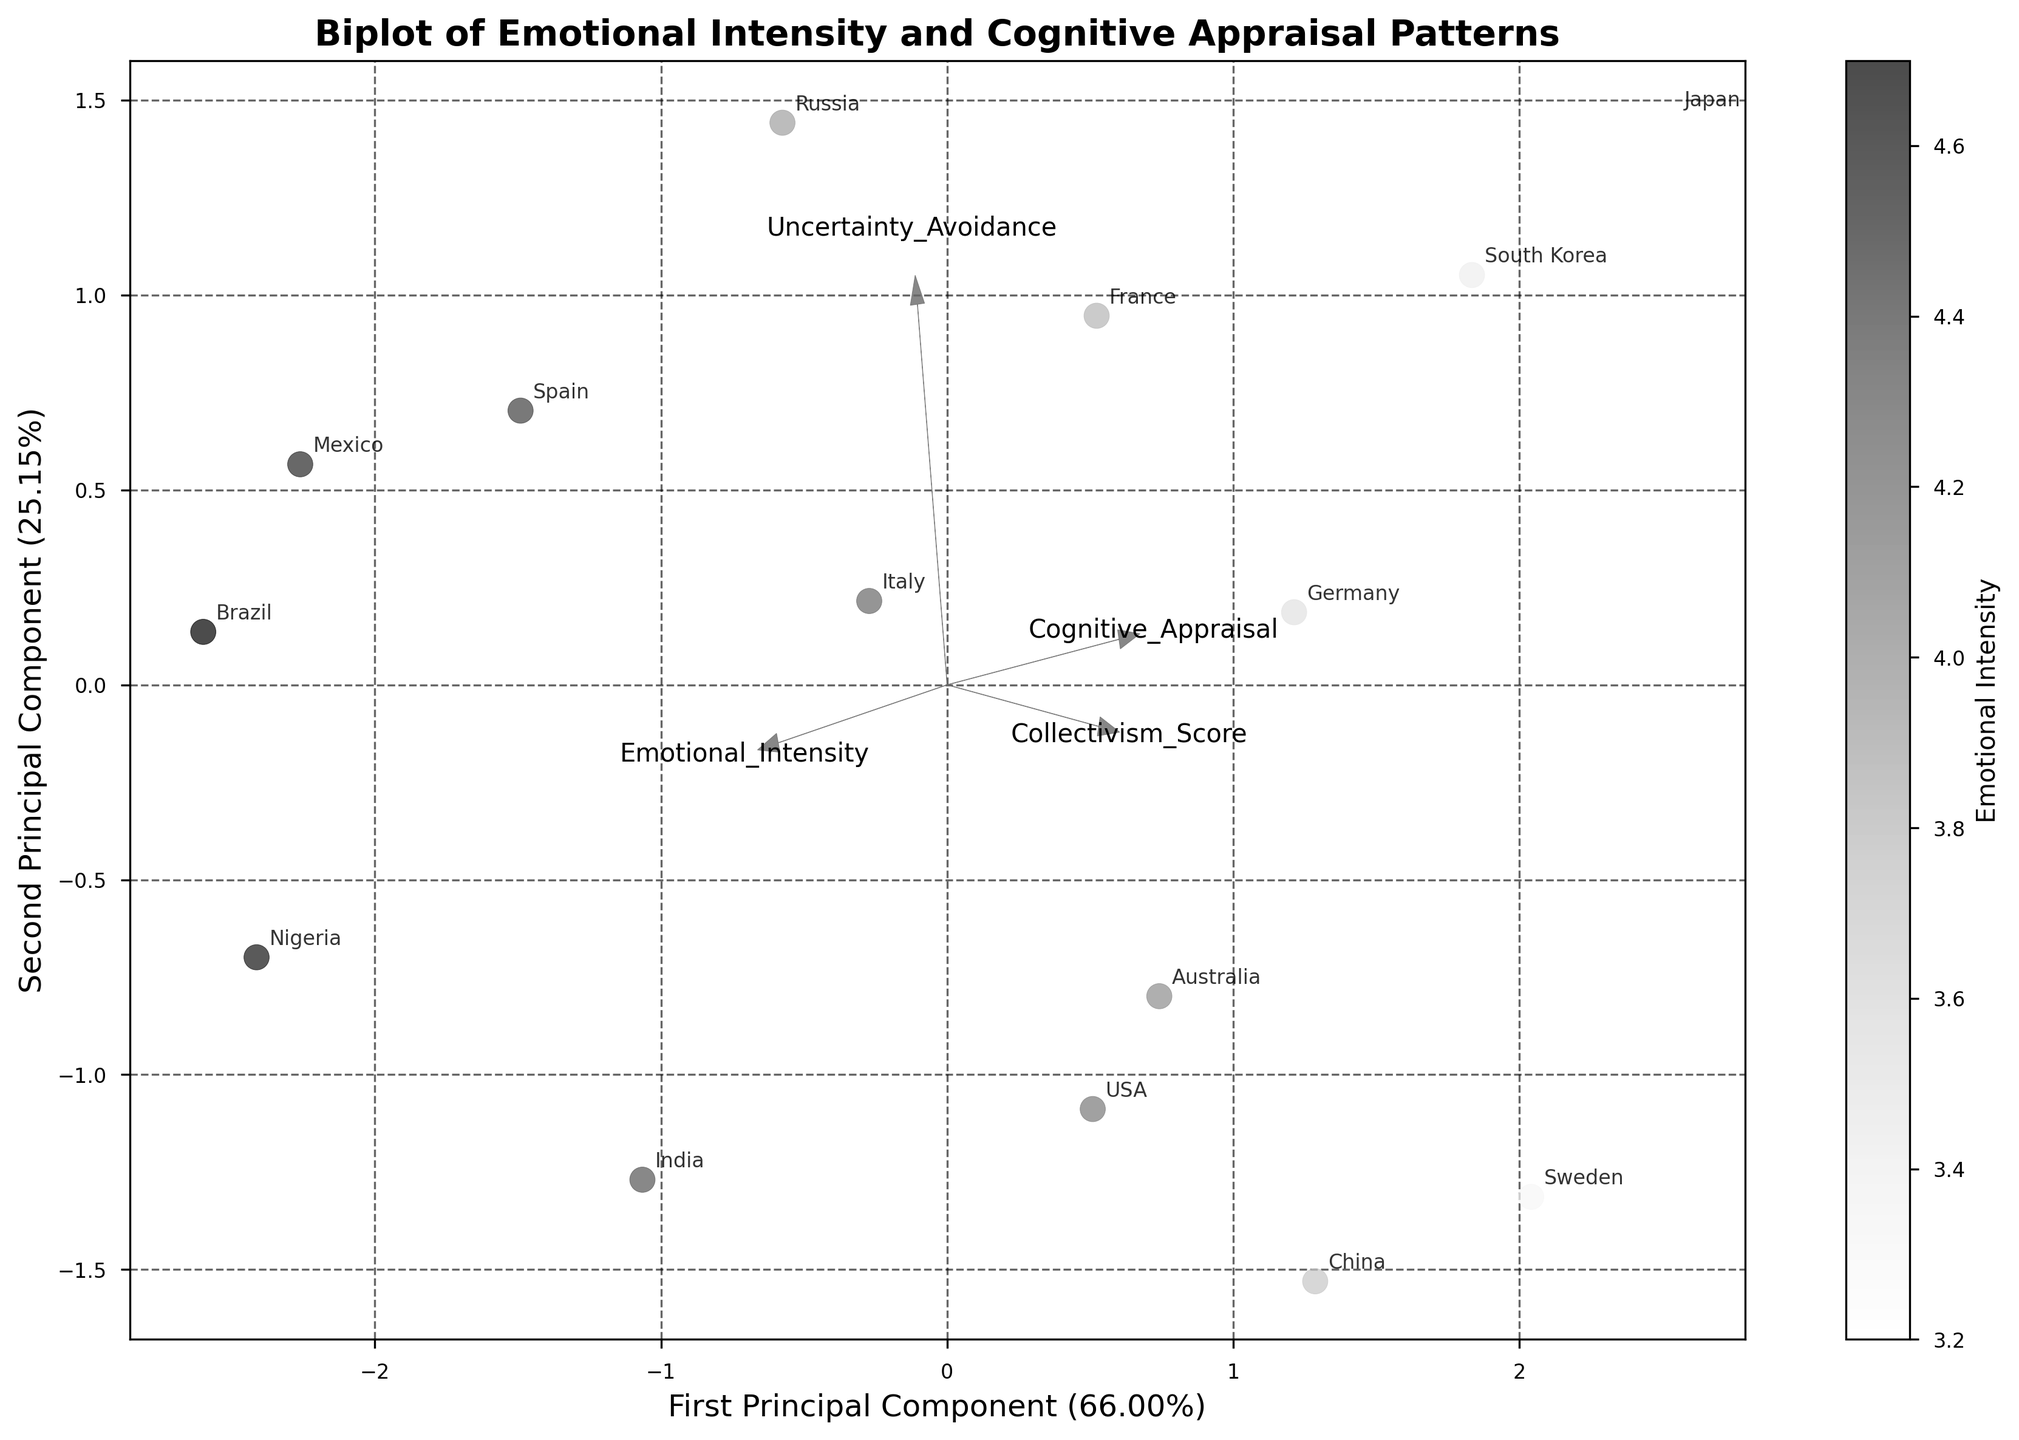What's the title of the plot? The title of the plot is usually displayed at the top. We can see "Biplot of Emotional Intensity and Cognitive Appraisal Patterns."
Answer: Biplot of Emotional Intensity and Cognitive Appraisal Patterns Which axis represents the first principal component? The axis labels typically provide this information. The x-axis is labeled as "First Principal Component," which indicates that it represents the first principal component.
Answer: x-axis What's the color bar label? The color bar on the side of the plot usually has a label indicating what the colors represent. In this case, the label is "Emotional Intensity."
Answer: Emotional Intensity How many cultures are represented in the plot? By counting the number of unique culture labels or points in the plot, we can determine the number of cultures. From the data, there are 15 cultures.
Answer: 15 Which culture appears to have the highest Emotional Intensity? The color bar indicates Emotional Intensity values. By looking at the darkest or most intense points, we can determine that Brazil has the highest Emotional Intensity.
Answer: Brazil Which two cultures are closest to each other in the PCA space? By observing which points are most closely located to each other on the plot, we can determine that USA and Australia are closest to each other in the PCA space.
Answer: USA and Australia What percentage of the variance is explained by the first principal component? This information is found in the x-axis label. The first principal component explains 37.47% of the variance.
Answer: 37.47% Which feature has the largest absolute contribution to the first principal component? We identify the feature whose arrow on the x-axis has the largest projection length. Emotional_Intensity has the largest length and thus, the largest contribution to the first principal component.
Answer: Emotional_Intensity Is the Collectivism_Score positively or negatively correlated with the first principal component? By examining the direction of the arrow for Collectivism_Score relative to the x-axis, we observe that it points to the right, indicating a positive correlation with the first principal component.
Answer: Positively How does the variance explained by the second principal component compare to the first principal component? This information is found in the axis labels. The second principal component explains 29.38% of the variance, which is less than the 37.47% explained by the first principal component.
Answer: Less 